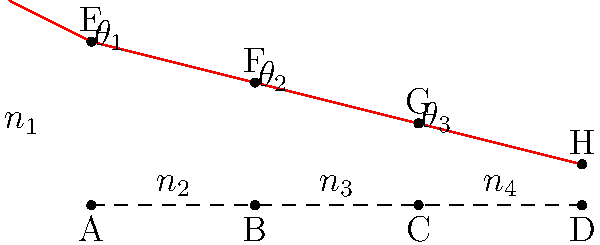A laser beam passes through multiple optical interfaces as shown in the diagram. The refractive indices of the materials are $n_1$, $n_2$, $n_3$, and $n_4$, respectively. If $\theta_1 = 30°$, $n_1 = 1.0$, $n_2 = 1.5$, $n_3 = 1.8$, and $n_4 = 1.6$, calculate the angle $\theta_3$ at which the laser beam enters the fourth medium. To solve this problem, we need to apply Snell's law at each interface:

1. At the first interface (between $n_1$ and $n_2$):
   $$n_1 \sin(\theta_1) = n_2 \sin(\theta_2)$$
   $$1.0 \sin(30°) = 1.5 \sin(\theta_2)$$
   $$\theta_2 = \arcsin(\frac{1.0 \sin(30°)}{1.5}) \approx 19.47°$$

2. At the second interface (between $n_2$ and $n_3$):
   $$n_2 \sin(\theta_2) = n_3 \sin(\theta_3)$$
   $$1.5 \sin(19.47°) = 1.8 \sin(\theta_3)$$
   $$\theta_3 = \arcsin(\frac{1.5 \sin(19.47°)}{1.8}) \approx 16.14°$$

3. At the third interface (between $n_3$ and $n_4$):
   We need to find $\theta_3'$ (the angle in $n_4$)
   $$n_3 \sin(\theta_3) = n_4 \sin(\theta_3')$$
   $$1.8 \sin(16.14°) = 1.6 \sin(\theta_3')$$
   $$\theta_3' = \arcsin(\frac{1.8 \sin(16.14°)}{1.6}) \approx 18.22°$$

Therefore, the angle $\theta_3$ at which the laser beam enters the fourth medium is approximately 18.22°.
Answer: 18.22° 